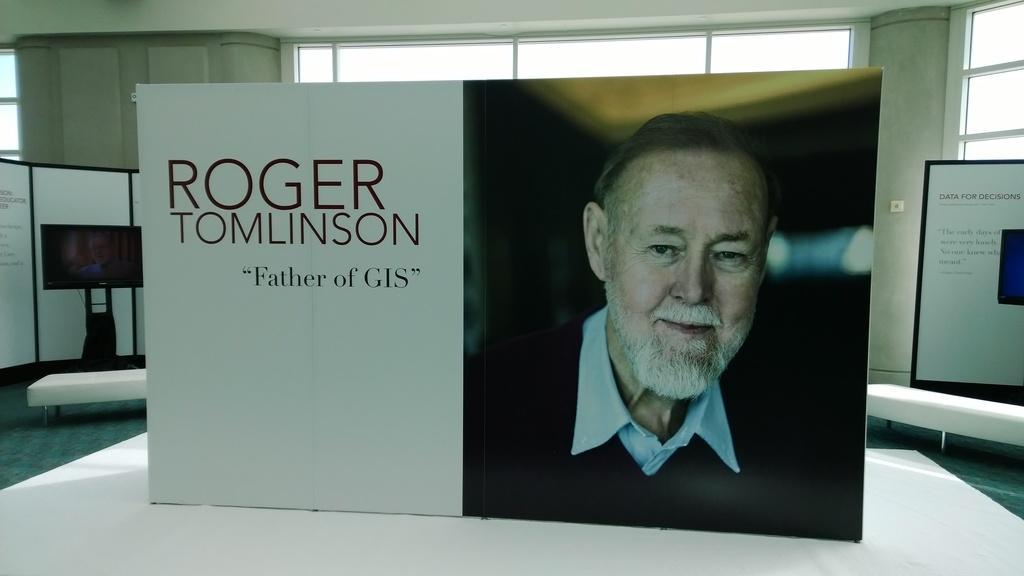Please provide a concise description of this image. In this picture we can see banners, television, windows and in a banner we can see a man smiling. 